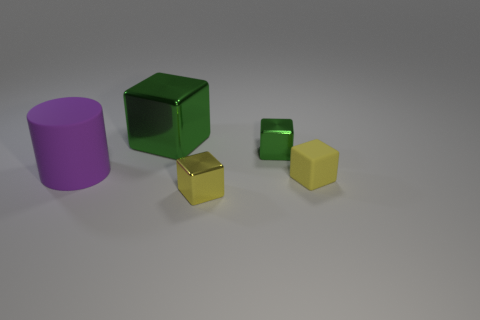How many rubber things are both right of the large purple matte thing and on the left side of the yellow metallic block?
Your answer should be very brief. 0. How many cubes are on the left side of the yellow metallic object?
Your answer should be compact. 1. Are there any big green objects that have the same shape as the yellow matte object?
Keep it short and to the point. Yes. There is a big green shiny thing; is it the same shape as the shiny object that is in front of the purple matte cylinder?
Offer a terse response. Yes. How many cylinders are green objects or small shiny things?
Offer a terse response. 0. What is the shape of the rubber thing that is left of the large shiny thing?
Make the answer very short. Cylinder. How many purple objects have the same material as the small green thing?
Make the answer very short. 0. Is the number of yellow metal cubes behind the large shiny thing less than the number of tiny gray rubber cubes?
Ensure brevity in your answer.  No. How big is the object on the left side of the big object right of the purple rubber object?
Offer a very short reply. Large. Does the big cube have the same color as the small metal cube to the right of the yellow metal object?
Ensure brevity in your answer.  Yes. 